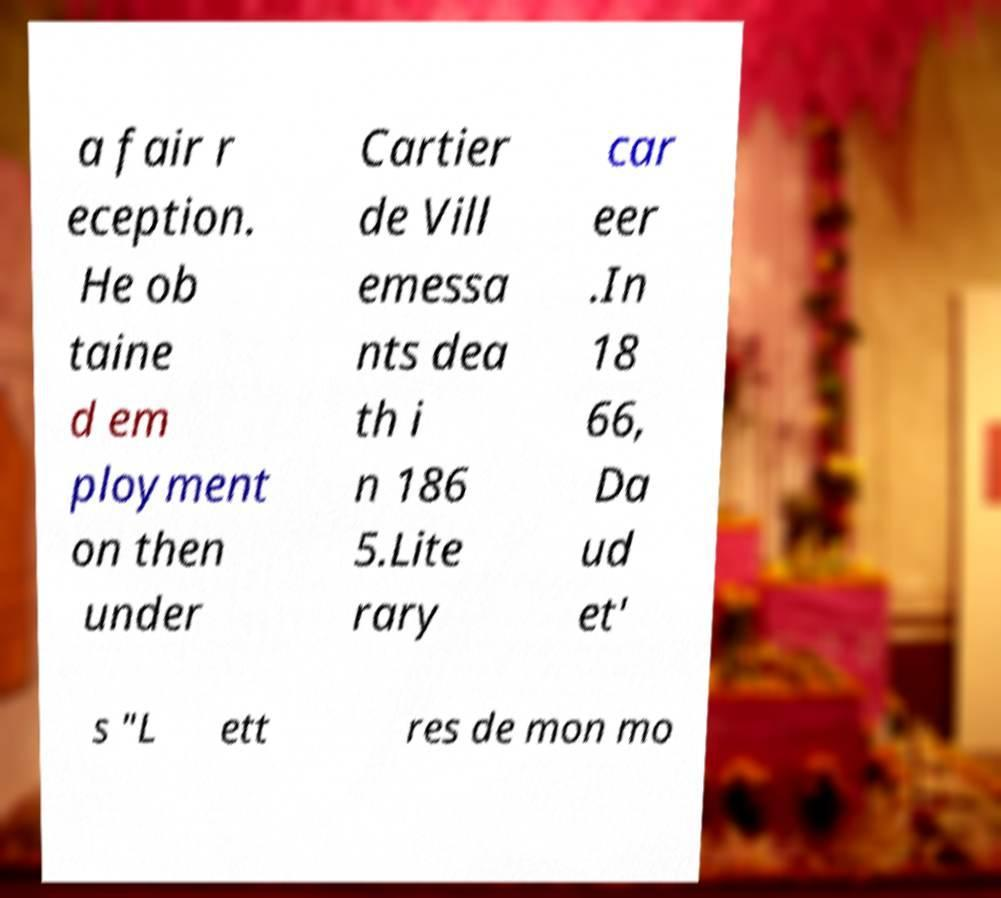I need the written content from this picture converted into text. Can you do that? a fair r eception. He ob taine d em ployment on then under Cartier de Vill emessa nts dea th i n 186 5.Lite rary car eer .In 18 66, Da ud et' s "L ett res de mon mo 